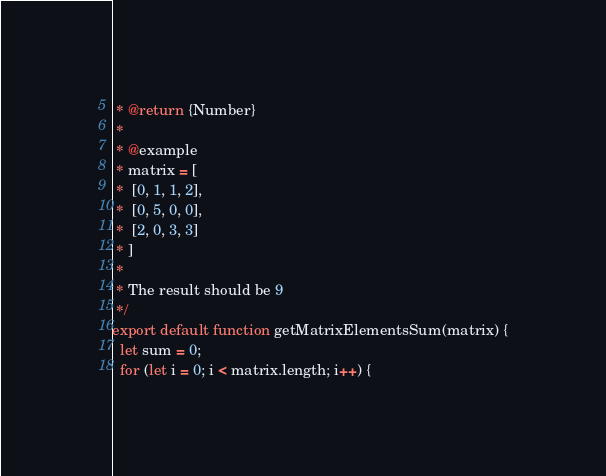Convert code to text. <code><loc_0><loc_0><loc_500><loc_500><_JavaScript_> * @return {Number}
 *
 * @example
 * matrix = [
 *  [0, 1, 1, 2],
 *  [0, 5, 0, 0],
 *  [2, 0, 3, 3]
 * ]
 *
 * The result should be 9
 */
export default function getMatrixElementsSum(matrix) {
  let sum = 0;
  for (let i = 0; i < matrix.length; i++) {</code> 